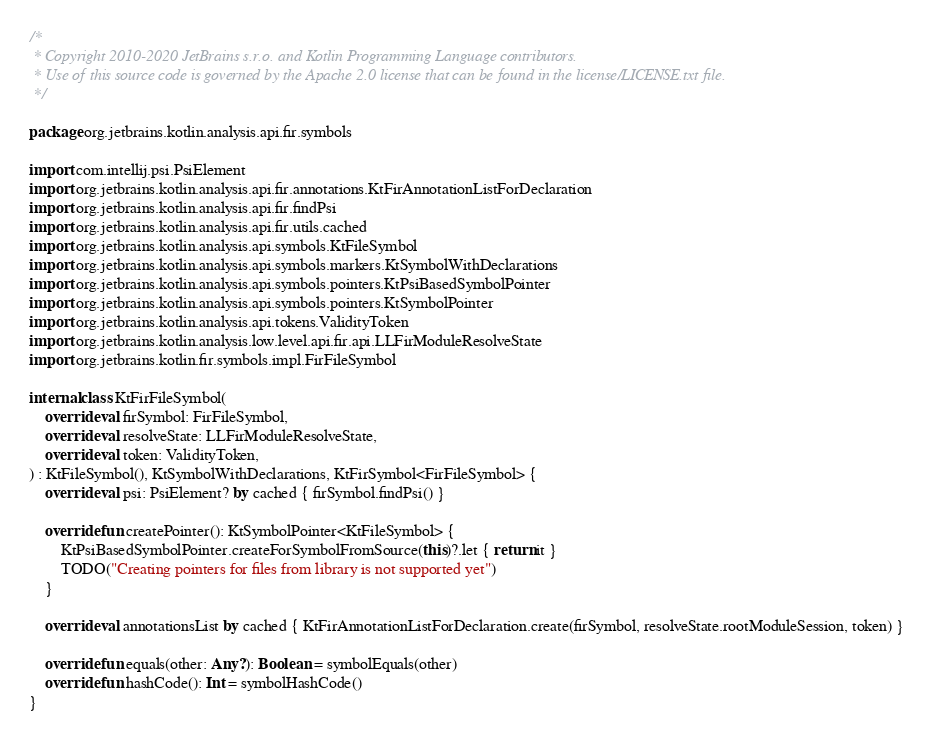Convert code to text. <code><loc_0><loc_0><loc_500><loc_500><_Kotlin_>/*
 * Copyright 2010-2020 JetBrains s.r.o. and Kotlin Programming Language contributors.
 * Use of this source code is governed by the Apache 2.0 license that can be found in the license/LICENSE.txt file.
 */

package org.jetbrains.kotlin.analysis.api.fir.symbols

import com.intellij.psi.PsiElement
import org.jetbrains.kotlin.analysis.api.fir.annotations.KtFirAnnotationListForDeclaration
import org.jetbrains.kotlin.analysis.api.fir.findPsi
import org.jetbrains.kotlin.analysis.api.fir.utils.cached
import org.jetbrains.kotlin.analysis.api.symbols.KtFileSymbol
import org.jetbrains.kotlin.analysis.api.symbols.markers.KtSymbolWithDeclarations
import org.jetbrains.kotlin.analysis.api.symbols.pointers.KtPsiBasedSymbolPointer
import org.jetbrains.kotlin.analysis.api.symbols.pointers.KtSymbolPointer
import org.jetbrains.kotlin.analysis.api.tokens.ValidityToken
import org.jetbrains.kotlin.analysis.low.level.api.fir.api.LLFirModuleResolveState
import org.jetbrains.kotlin.fir.symbols.impl.FirFileSymbol

internal class KtFirFileSymbol(
    override val firSymbol: FirFileSymbol,
    override val resolveState: LLFirModuleResolveState,
    override val token: ValidityToken,
) : KtFileSymbol(), KtSymbolWithDeclarations, KtFirSymbol<FirFileSymbol> {
    override val psi: PsiElement? by cached { firSymbol.findPsi() }

    override fun createPointer(): KtSymbolPointer<KtFileSymbol> {
        KtPsiBasedSymbolPointer.createForSymbolFromSource(this)?.let { return it }
        TODO("Creating pointers for files from library is not supported yet")
    }

    override val annotationsList by cached { KtFirAnnotationListForDeclaration.create(firSymbol, resolveState.rootModuleSession, token) }

    override fun equals(other: Any?): Boolean = symbolEquals(other)
    override fun hashCode(): Int = symbolHashCode()
}
</code> 